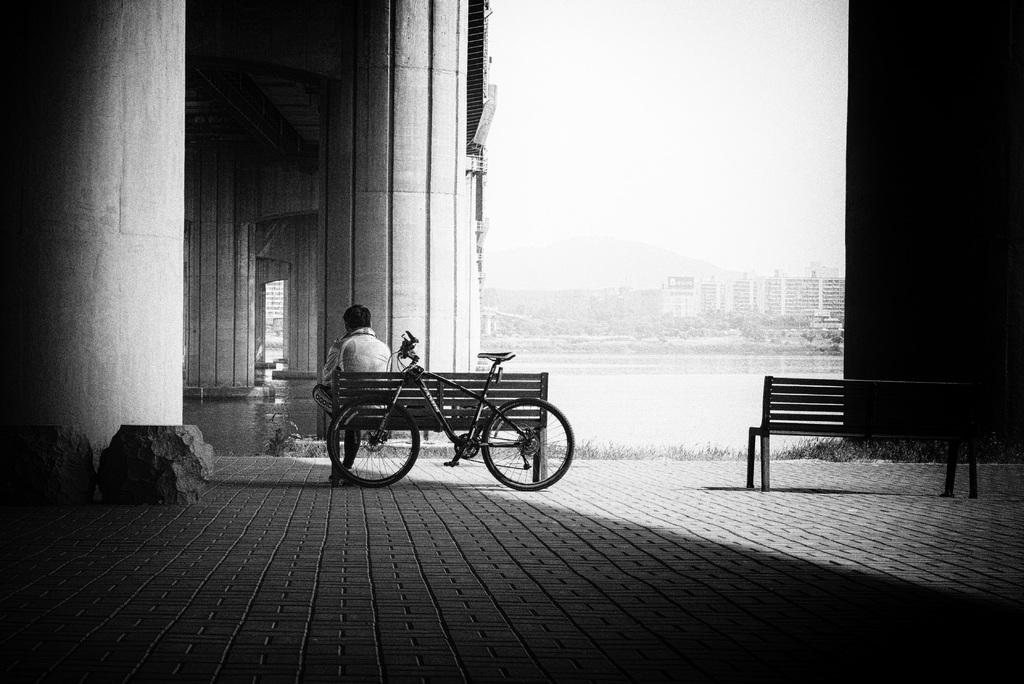What type of structures can be seen in the distance? There are buildings in the distance. What kind of architectural feature is present in the image? There is a bridge with pillars in the image. How many benches are visible in the image? There are 2 benches in the image. What is the man on the bench doing? A man is sitting on one of the benches. What is beside the bench with the man? There is a bicycle beside the bench with the man. What type of water body is present in the image? The image features a freshwater river. Can you see any steam coming from the bicycle in the image? There is no steam present in the image; it features a man sitting on a bench with a bicycle beside him. What type of surprise is the man holding in the image? There is no surprise present in the image; the man is simply sitting on a bench. 